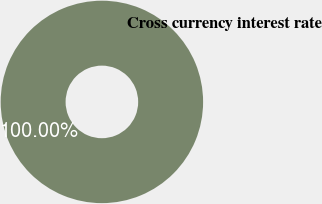Convert chart to OTSL. <chart><loc_0><loc_0><loc_500><loc_500><pie_chart><fcel>Cross currency interest rate<nl><fcel>100.0%<nl></chart> 